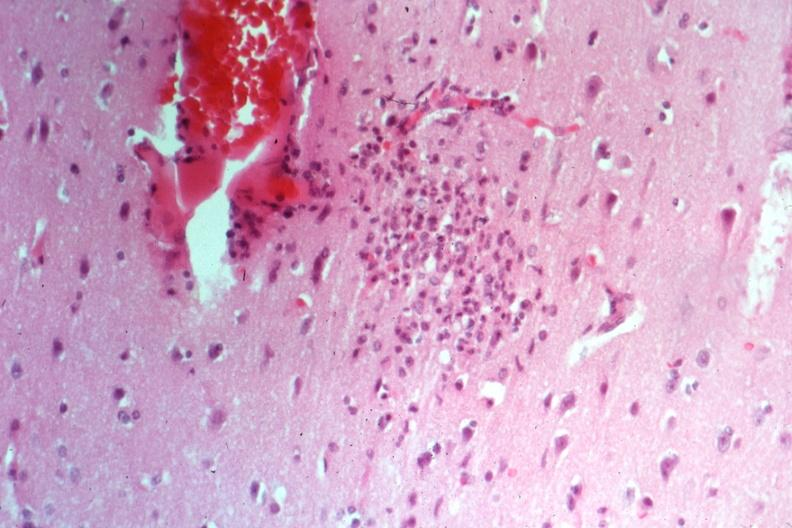s brain present?
Answer the question using a single word or phrase. Yes 